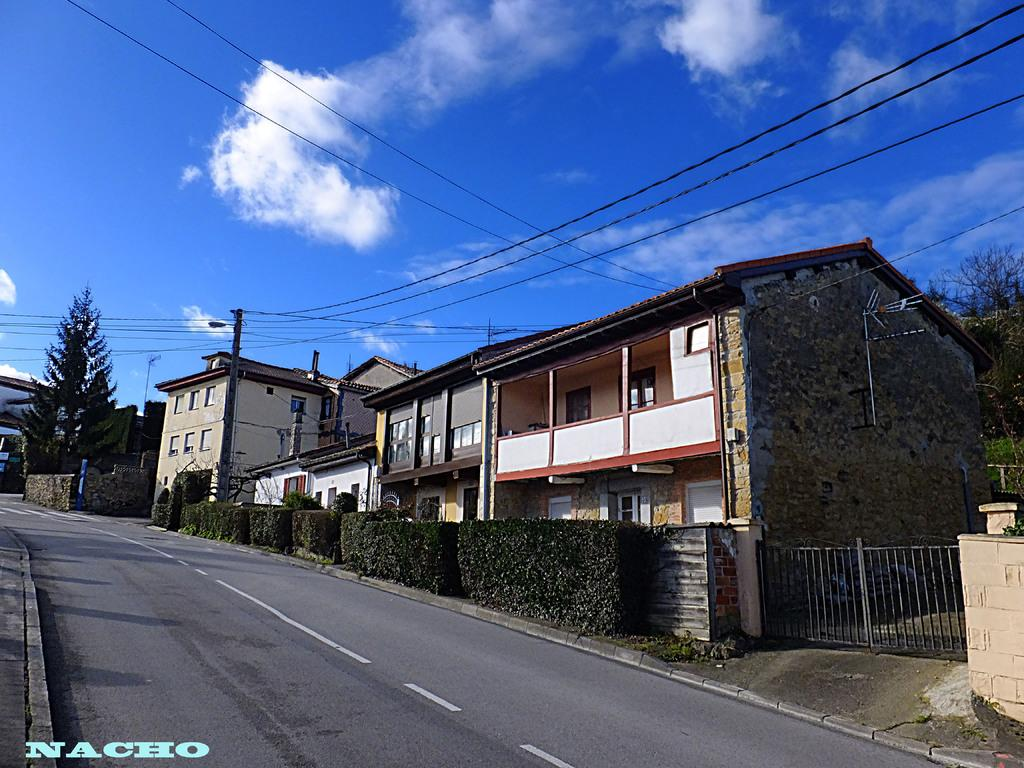<image>
Summarize the visual content of the image. A picture of a neighborhood street with some homes and a Nacho watermark in the bottom left corner. 